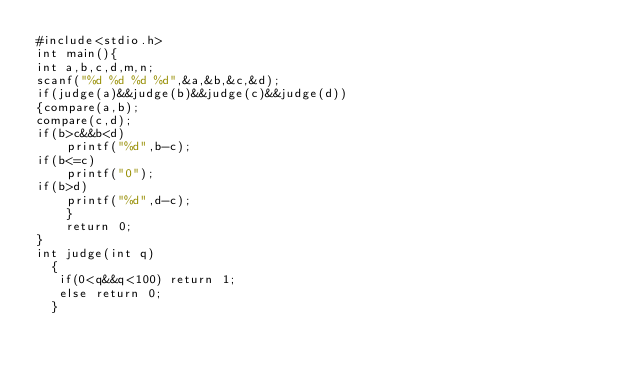<code> <loc_0><loc_0><loc_500><loc_500><_C_>#include<stdio.h>
int main(){
int a,b,c,d,m,n;
scanf("%d %d %d %d",&a,&b,&c,&d);
if(judge(a)&&judge(b)&&judge(c)&&judge(d))
{compare(a,b);
compare(c,d);
if(b>c&&b<d)
    printf("%d",b-c);
if(b<=c)
    printf("0");
if(b>d)
    printf("%d",d-c);
    }
    return 0;
}
int judge(int q)
  {
   if(0<q&&q<100) return 1;
   else return 0;
  }</code> 